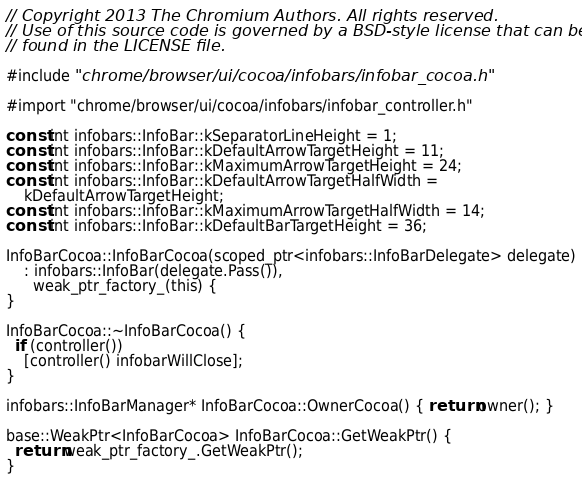<code> <loc_0><loc_0><loc_500><loc_500><_ObjectiveC_>// Copyright 2013 The Chromium Authors. All rights reserved.
// Use of this source code is governed by a BSD-style license that can be
// found in the LICENSE file.

#include "chrome/browser/ui/cocoa/infobars/infobar_cocoa.h"

#import "chrome/browser/ui/cocoa/infobars/infobar_controller.h"

const int infobars::InfoBar::kSeparatorLineHeight = 1;
const int infobars::InfoBar::kDefaultArrowTargetHeight = 11;
const int infobars::InfoBar::kMaximumArrowTargetHeight = 24;
const int infobars::InfoBar::kDefaultArrowTargetHalfWidth =
    kDefaultArrowTargetHeight;
const int infobars::InfoBar::kMaximumArrowTargetHalfWidth = 14;
const int infobars::InfoBar::kDefaultBarTargetHeight = 36;

InfoBarCocoa::InfoBarCocoa(scoped_ptr<infobars::InfoBarDelegate> delegate)
    : infobars::InfoBar(delegate.Pass()),
      weak_ptr_factory_(this) {
}

InfoBarCocoa::~InfoBarCocoa() {
  if (controller())
    [controller() infobarWillClose];
}

infobars::InfoBarManager* InfoBarCocoa::OwnerCocoa() { return owner(); }

base::WeakPtr<InfoBarCocoa> InfoBarCocoa::GetWeakPtr() {
  return weak_ptr_factory_.GetWeakPtr();
}
</code> 